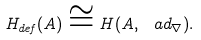Convert formula to latex. <formula><loc_0><loc_0><loc_500><loc_500>H _ { d e f } ( A ) \cong H ( A , \ a d _ { \nabla } ) .</formula> 